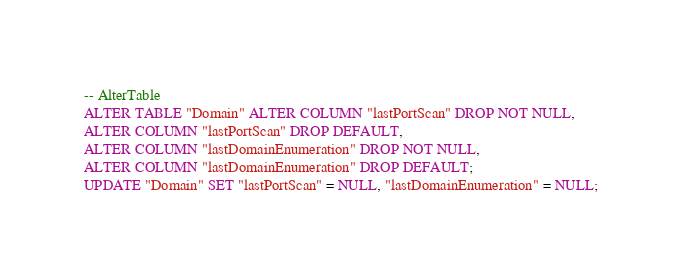Convert code to text. <code><loc_0><loc_0><loc_500><loc_500><_SQL_>-- AlterTable
ALTER TABLE "Domain" ALTER COLUMN "lastPortScan" DROP NOT NULL,
ALTER COLUMN "lastPortScan" DROP DEFAULT,
ALTER COLUMN "lastDomainEnumeration" DROP NOT NULL,
ALTER COLUMN "lastDomainEnumeration" DROP DEFAULT;
UPDATE "Domain" SET "lastPortScan" = NULL, "lastDomainEnumeration" = NULL;

</code> 